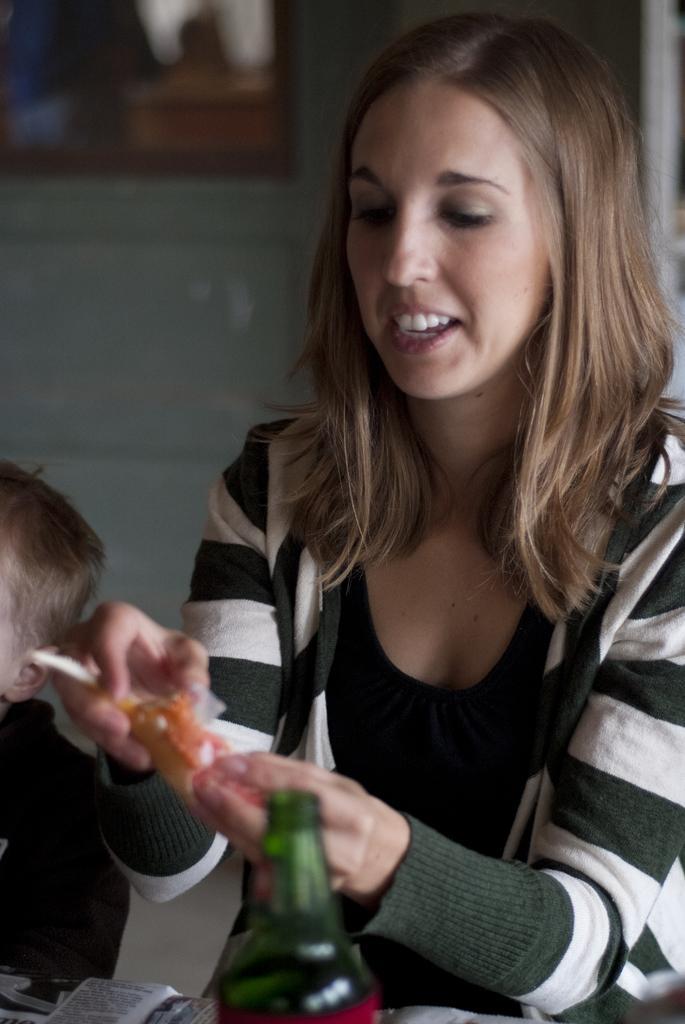Please provide a concise description of this image. In this picture we can see a woman holding object, side we can see a boy, in front one table is placed on it few objects are placed. 